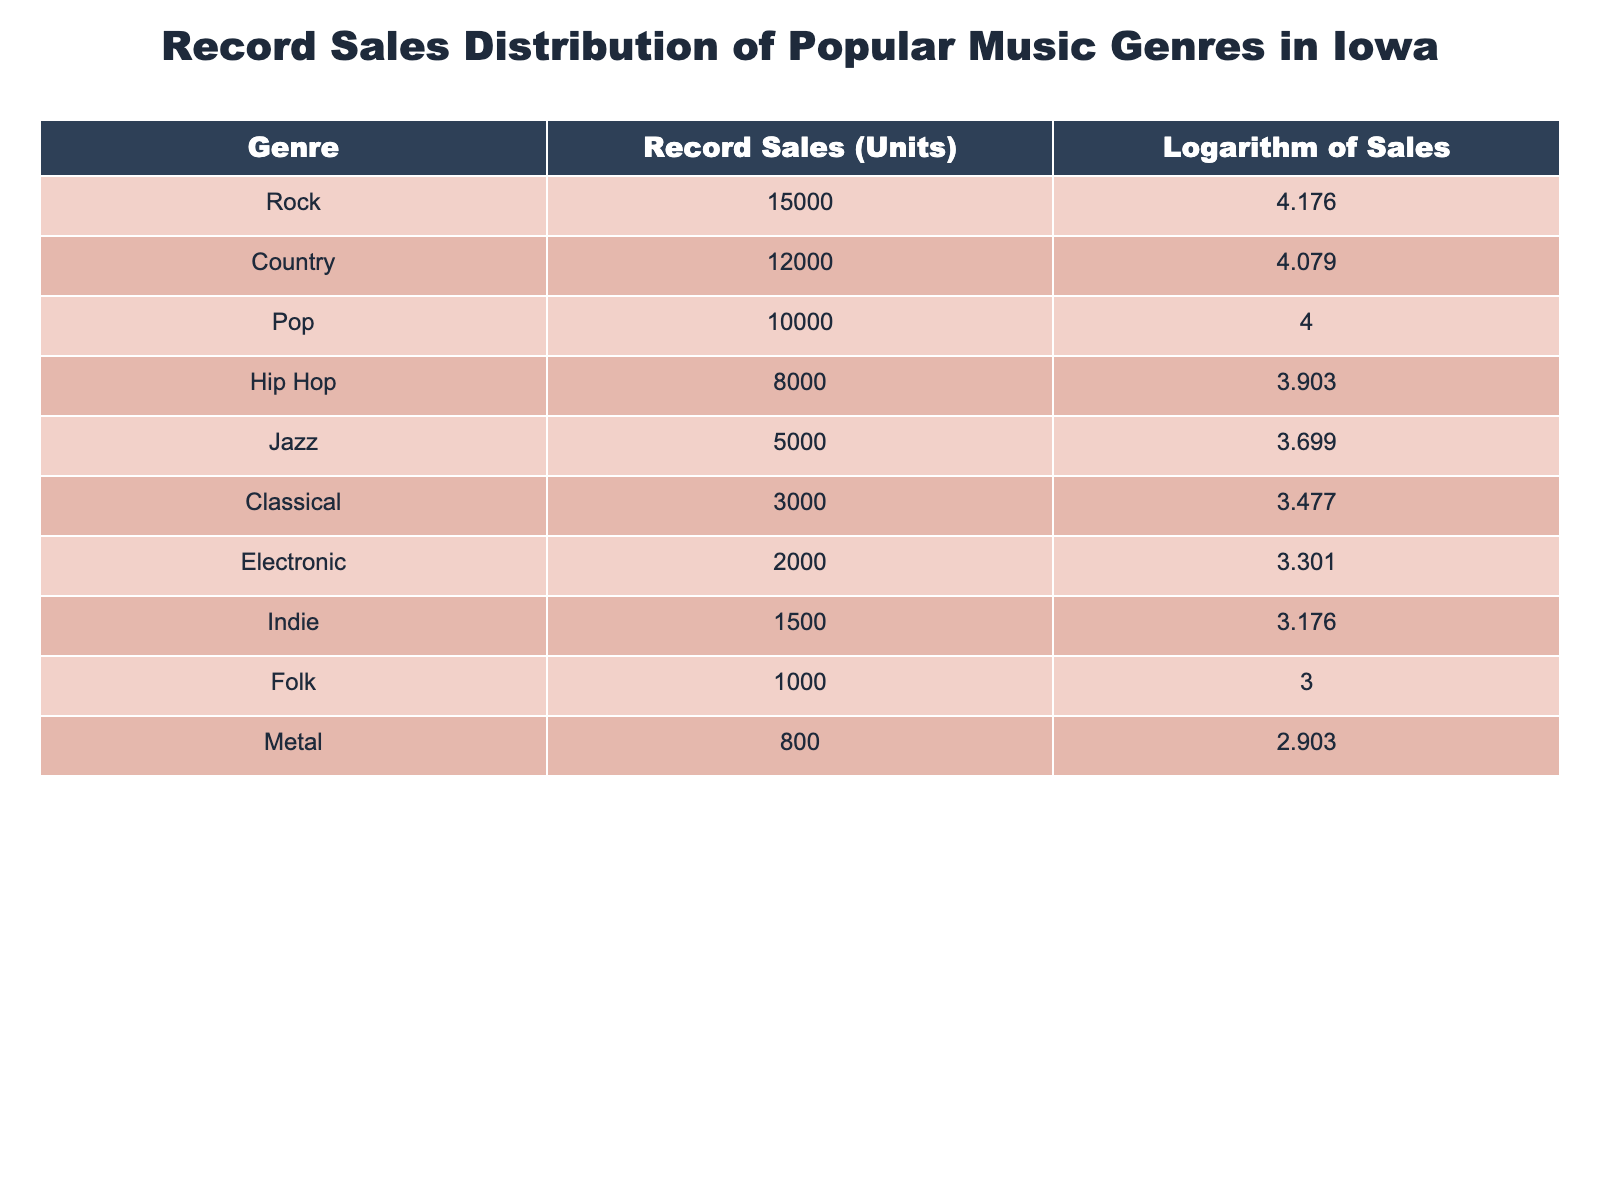What genre has the highest record sales in Iowa? From the table, we can observe the "Record Sales (Units)" column. "Rock" has the highest sales at 15,000 units compared to other genres listed.
Answer: Rock What genre has the lowest record sales in Iowa? Looking at the "Record Sales (Units)" column again, "Metal" has the lowest sales with 800 units.
Answer: Metal What is the total record sales for Country and Pop genres combined? To find the total sales for Country and Pop, we sum their individual record sales: Country (12,000) + Pop (10,000) = 22,000 units.
Answer: 22000 Is there a genre that has more than 10,000 record sales? By examining the "Record Sales (Units)" column, we see that Rock (15,000), Country (12,000), and Pop (10,000) have sales exceeding 10,000 units. Therefore, yes, there are genres with more than 10,000 sales.
Answer: Yes What is the difference in record sales between the Jazz and Electronic genres? The record sales for Jazz is 5,000 units, and for Electronic, it is 2,000 units. The difference is calculated as 5,000 - 2,000 = 3,000 units.
Answer: 3000 What is the average record sales for the top three genres in Iowa? The top three genres based on record sales are Rock (15,000), Country (12,000), and Pop (10,000). The total sales for these genres is 15,000 + 12,000 + 10,000 = 37,000 units. There are three genres, so the average is 37,000 / 3 = 12,333.33 units.
Answer: 12333.33 Is the number of Hip Hop sales greater than that of Jazz sales? Hip Hop sales are 8,000 units and Jazz sales are 5,000 units. Since 8,000 is greater than 5,000, the answer is yes.
Answer: Yes What is the logarithm value for the Indie genre sales? The table shows that the logarithm of sales for Indie is listed as 3.176 in the "Logarithm of Sales" column.
Answer: 3.176 Which two genres have record sales that are nearest to each other? Upon checking the "Record Sales (Units)" for the genres, we see that Folk has 1,000 units and Indie has 1,500 units. The difference is 500 units, which is the smallest among all pairs.
Answer: Folk and Indie 